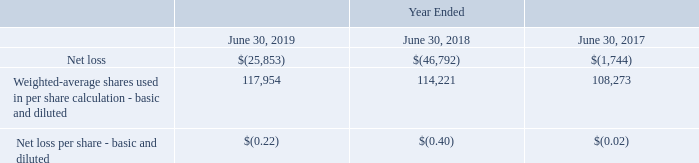16. Net Loss Per Share
Basic earnings per share is calculated by dividing net income by the weighted average number of common shares outstanding during the period, less shares subject to repurchase, and excludes any dilutive effects of options, warrants and unvested restricted stock. Dilutive earnings per share is calculated by dividing net income by the weighted average number of common shares used in the basic earnings per share calculation plus the dilutive effect of shares subject to options, warrants and unvested restricted stock.
The following table presents the calculation of basic and diluted net loss per share (in thousands, except per share data):
Potentially dilutive common shares from employee incentive plans are determined by applying the treasury stock method to the assumed exercise of outstanding stock options, the assumed vesting of outstanding restricted stock units, and the assumed issuance of common stock under the ESPP. Weighted stock options outstanding with an exercise price higher than the Company's average stock price for the periods presented are excluded from the calculation of diluted net loss per share since the effect of including them would have been anti-dilutive due to the net loss position of the Company during the periods presented.
How were Potentially dilutive common shares from employee incentive plans determined? By applying the treasury stock method to the assumed exercise of outstanding stock options, the assumed vesting of outstanding restricted stock units, and the assumed issuance of common stock under the espp. Which years does the table provide information for the calculation of basic and diluted net loss per share? 2019, 2018, 2017. What was the net loss in 2019?
Answer scale should be: thousand. (25,853). How many years did the basic and diluted Weighted-average shares used in per share calculation exceed 100,000 thousand? 2019##2018##2017
Answer: 3. What was the change in the net loss between 2018 and 2019?
Answer scale should be: thousand. -25,853-(-46,792)
Answer: 20939. What was the percentage change in the basic and diluted net loss per share between 2018 and 2019?
Answer scale should be: percent. (-0.22+0.40)/-0.40
Answer: -45. 